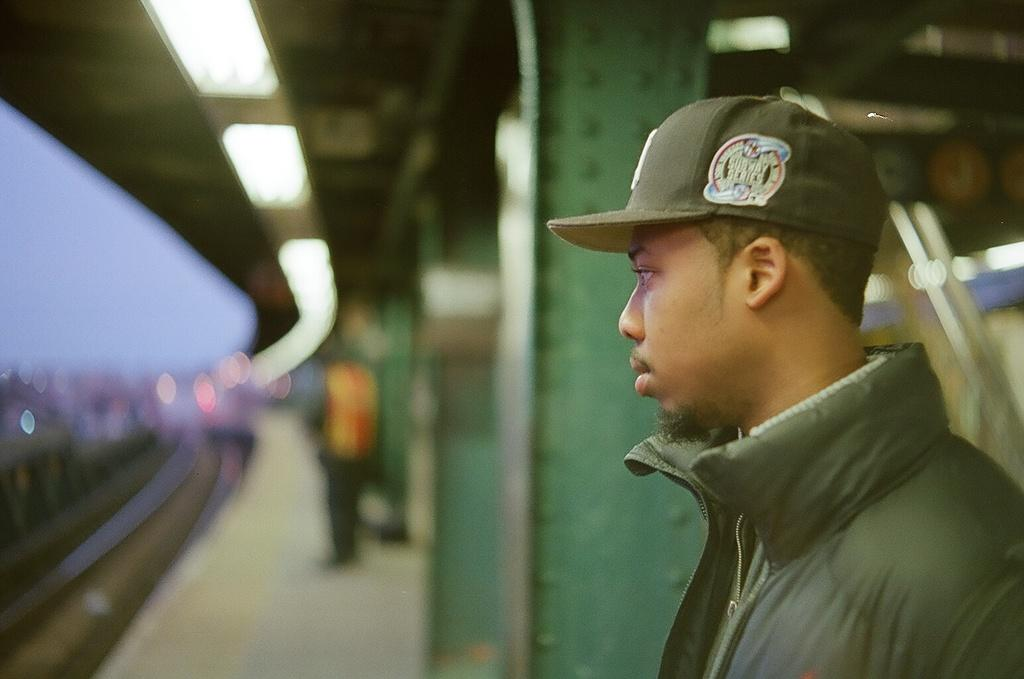Who or what is the main subject in the image? There is a person in the image. What structures are visible in the image? There are metal pillars in the image. What can be seen on the left side of the image? There is a railway track on the left side of the image. How would you describe the background of the image? The background of the image appears blurry. What is the reaction of the girls in the image when they see the person? There are no girls present in the image, so it is not possible to determine their reaction. 